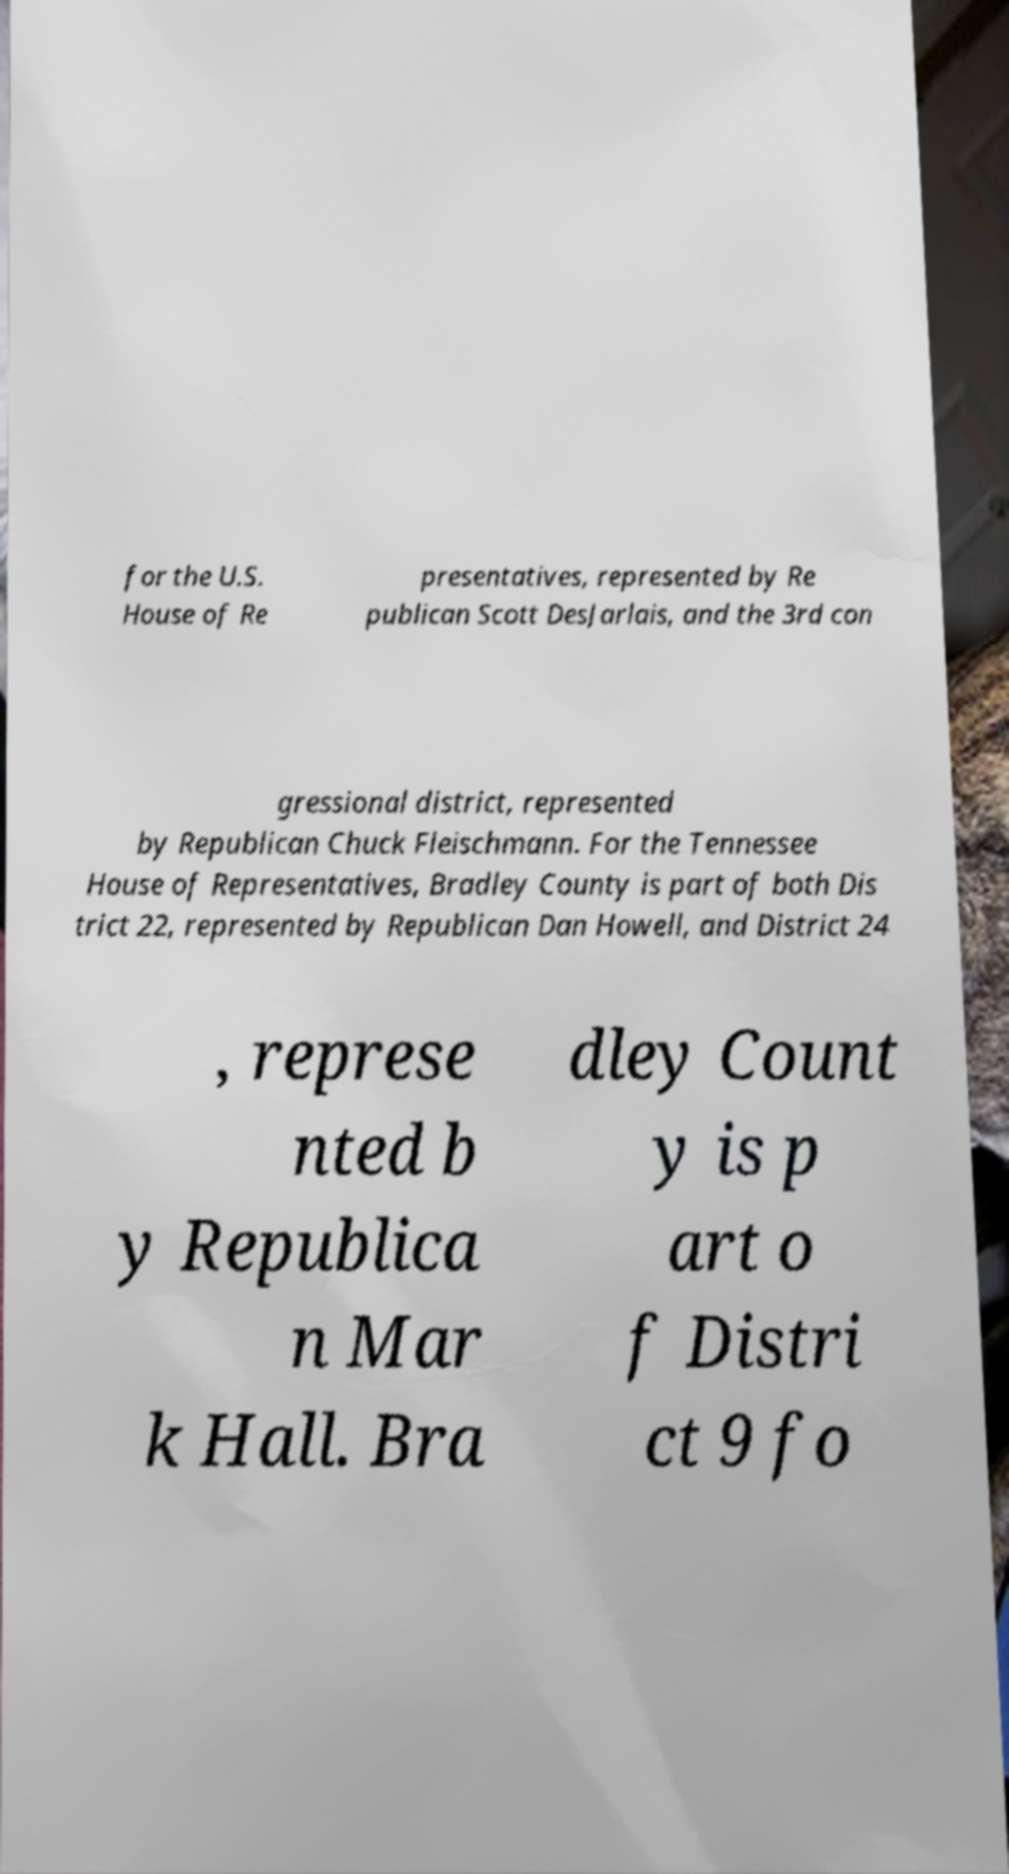Can you accurately transcribe the text from the provided image for me? for the U.S. House of Re presentatives, represented by Re publican Scott DesJarlais, and the 3rd con gressional district, represented by Republican Chuck Fleischmann. For the Tennessee House of Representatives, Bradley County is part of both Dis trict 22, represented by Republican Dan Howell, and District 24 , represe nted b y Republica n Mar k Hall. Bra dley Count y is p art o f Distri ct 9 fo 